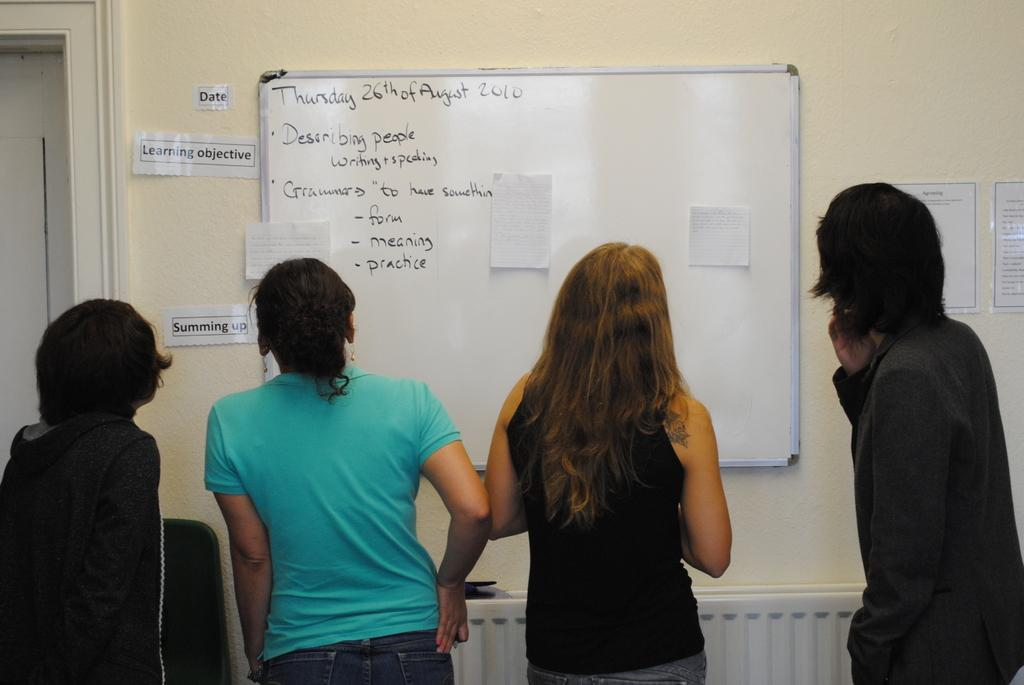<image>
Present a compact description of the photo's key features. Four people are looking at a board that says Thursday 26th of August 2010 at the top. 